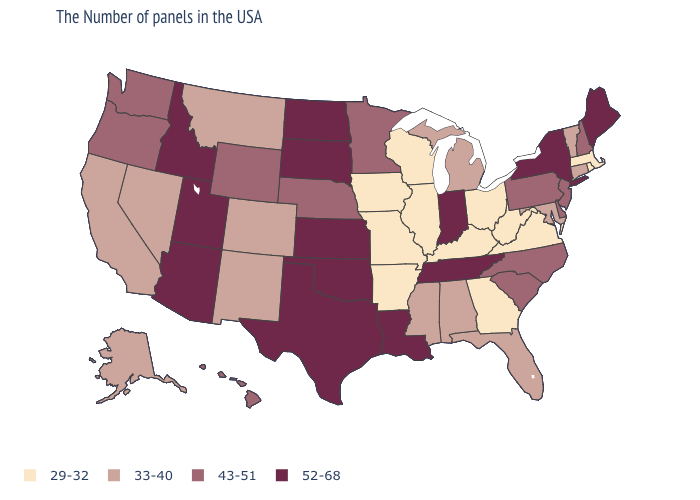Which states have the highest value in the USA?
Concise answer only. Maine, New York, Indiana, Tennessee, Louisiana, Kansas, Oklahoma, Texas, South Dakota, North Dakota, Utah, Arizona, Idaho. Does New Jersey have a lower value than Maryland?
Answer briefly. No. What is the value of Massachusetts?
Write a very short answer. 29-32. Which states have the lowest value in the USA?
Keep it brief. Massachusetts, Rhode Island, Virginia, West Virginia, Ohio, Georgia, Kentucky, Wisconsin, Illinois, Missouri, Arkansas, Iowa. Among the states that border West Virginia , which have the lowest value?
Quick response, please. Virginia, Ohio, Kentucky. What is the value of New Hampshire?
Concise answer only. 43-51. Name the states that have a value in the range 52-68?
Give a very brief answer. Maine, New York, Indiana, Tennessee, Louisiana, Kansas, Oklahoma, Texas, South Dakota, North Dakota, Utah, Arizona, Idaho. What is the value of Illinois?
Keep it brief. 29-32. Does the first symbol in the legend represent the smallest category?
Write a very short answer. Yes. What is the highest value in the West ?
Answer briefly. 52-68. Does North Dakota have a lower value than Arizona?
Short answer required. No. What is the value of Rhode Island?
Quick response, please. 29-32. Name the states that have a value in the range 52-68?
Answer briefly. Maine, New York, Indiana, Tennessee, Louisiana, Kansas, Oklahoma, Texas, South Dakota, North Dakota, Utah, Arizona, Idaho. Name the states that have a value in the range 43-51?
Be succinct. New Hampshire, New Jersey, Delaware, Pennsylvania, North Carolina, South Carolina, Minnesota, Nebraska, Wyoming, Washington, Oregon, Hawaii. Does Georgia have a lower value than Massachusetts?
Concise answer only. No. 